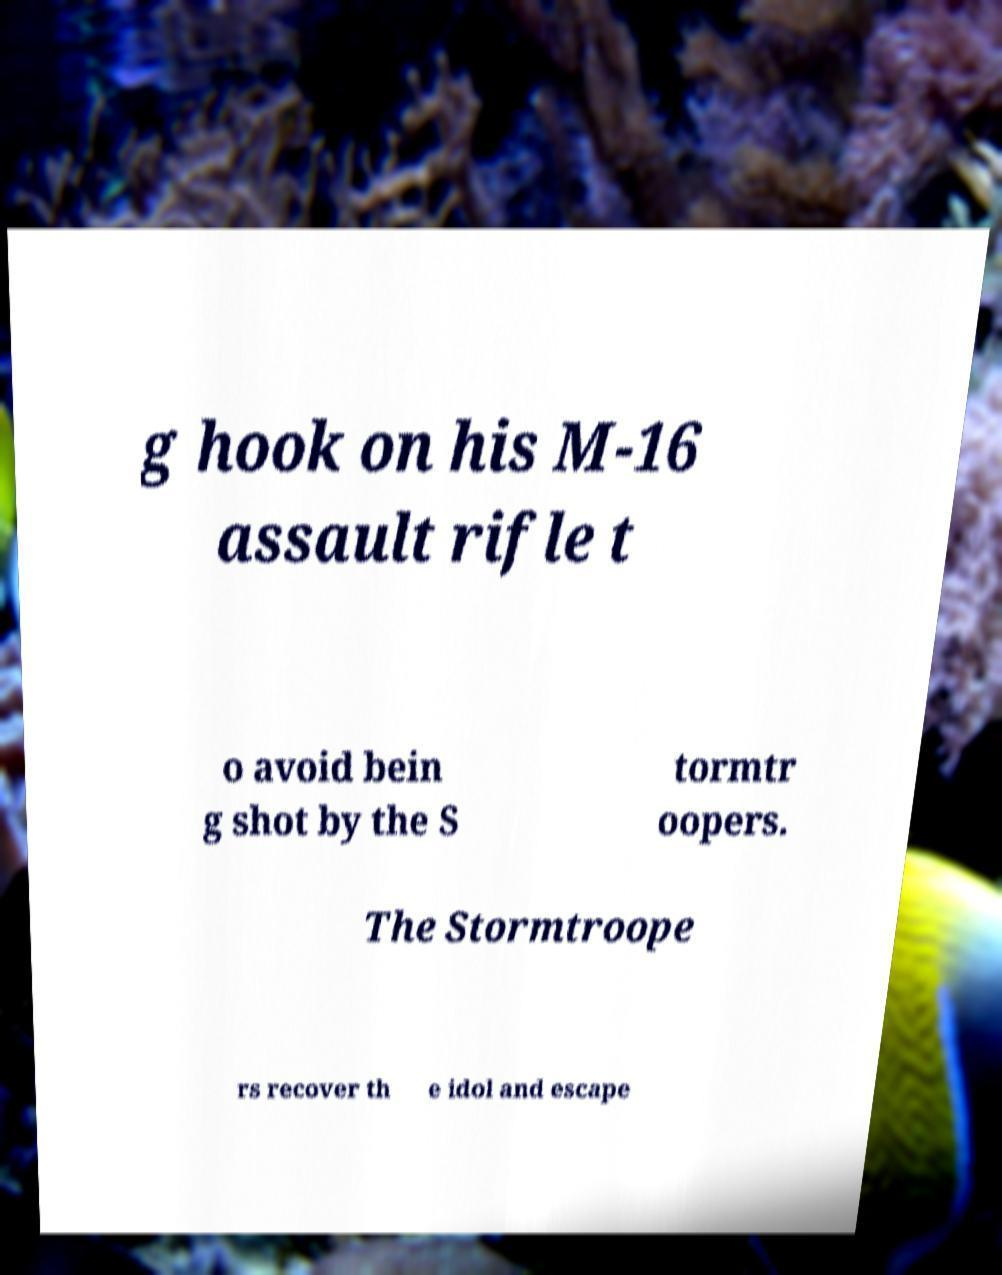For documentation purposes, I need the text within this image transcribed. Could you provide that? g hook on his M-16 assault rifle t o avoid bein g shot by the S tormtr oopers. The Stormtroope rs recover th e idol and escape 